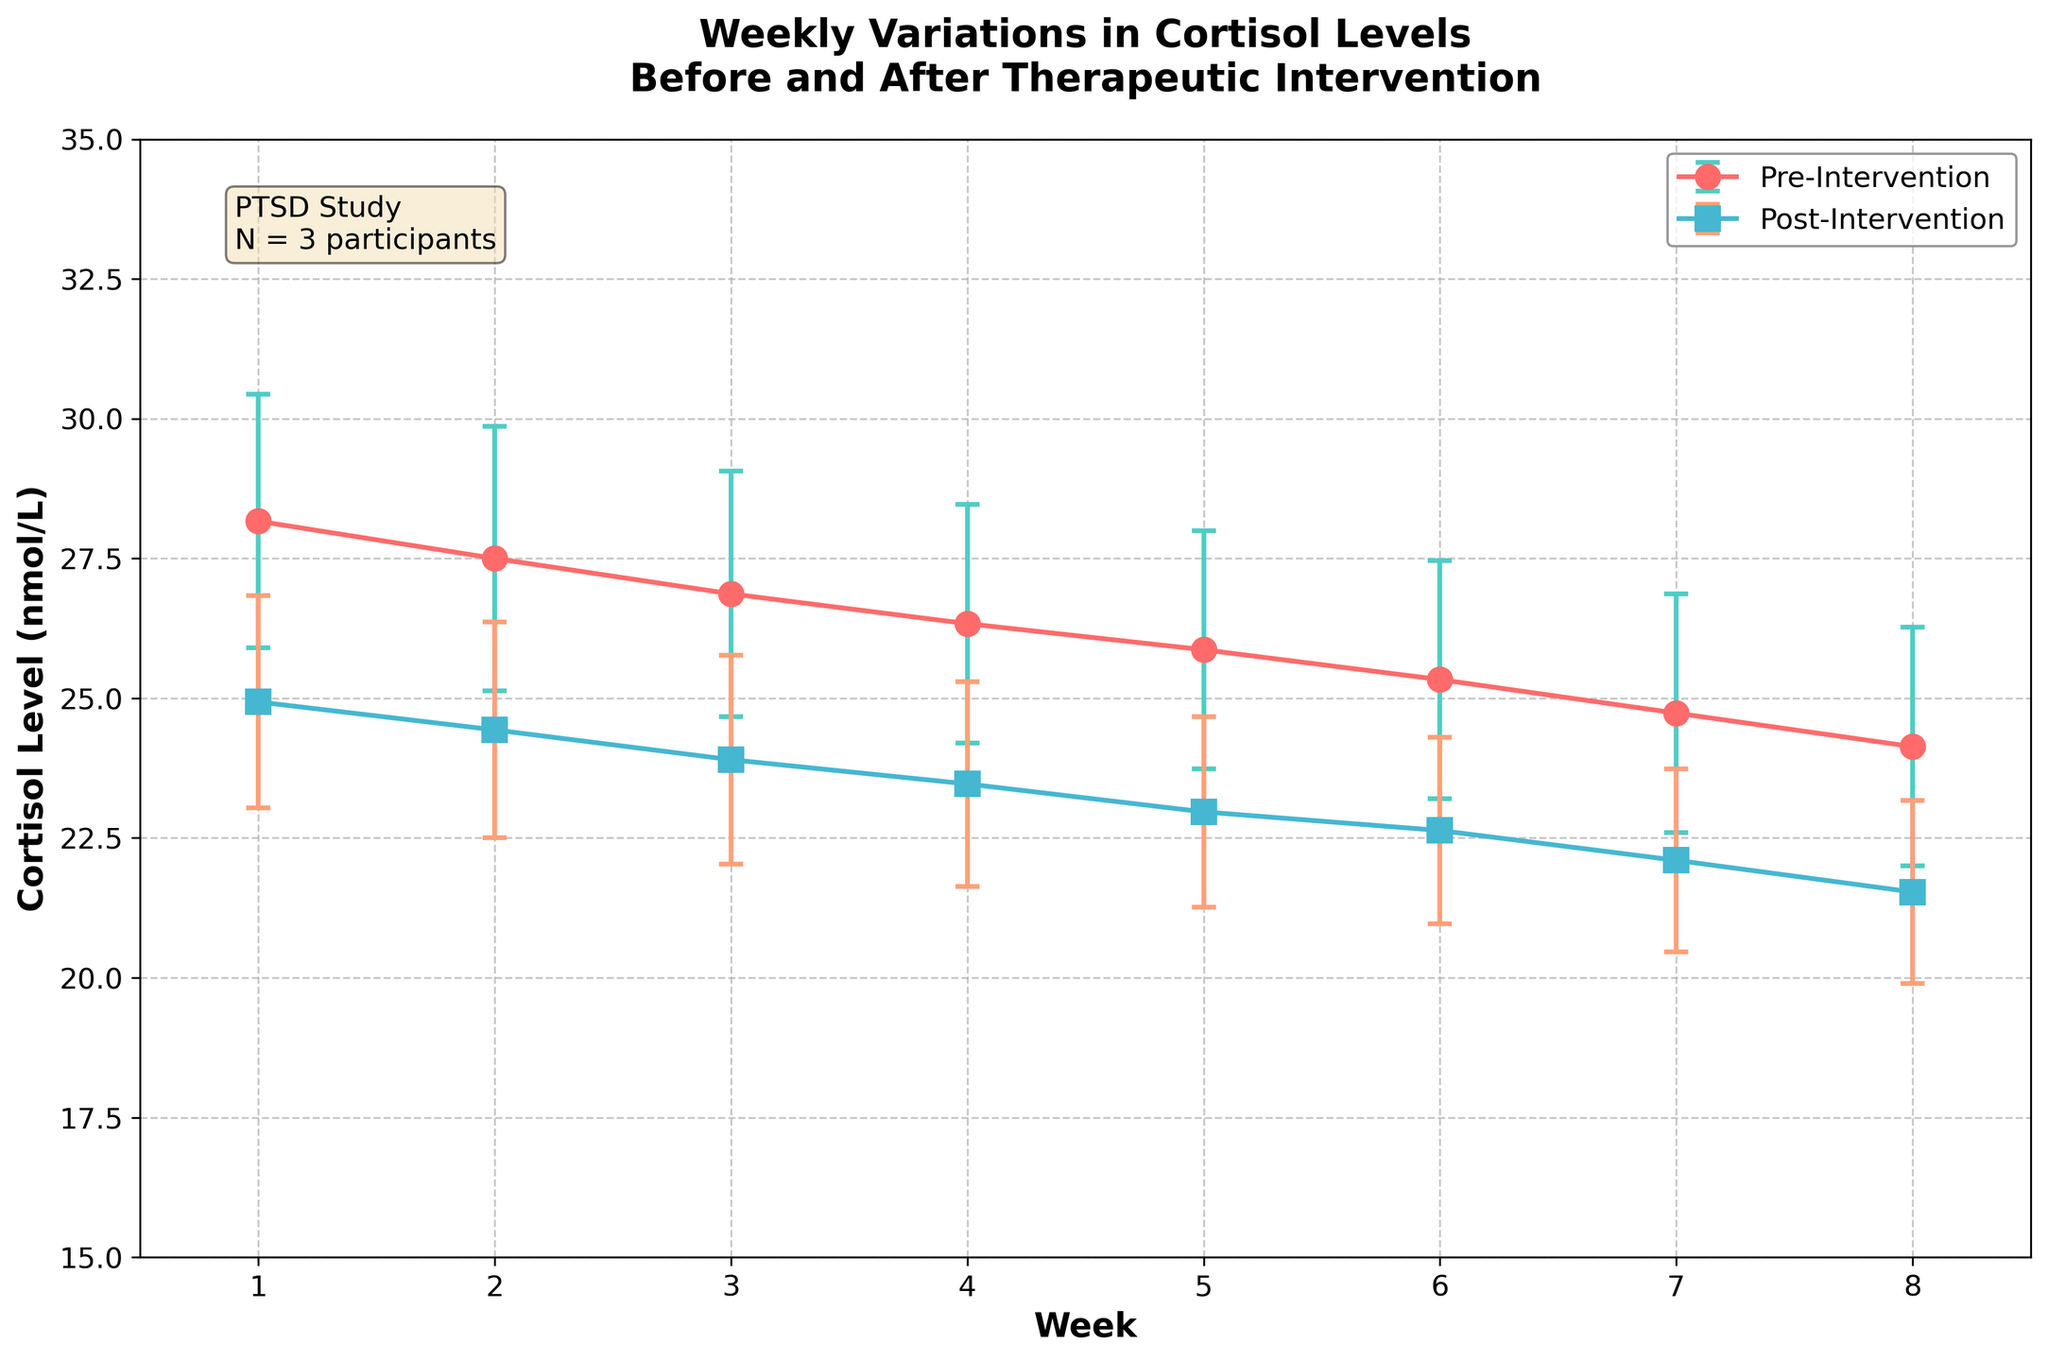What is the title of the figure? The title can be found at the top of the figure, usually in a larger and bolder font. In this case, it reads 'Weekly Variations in Cortisol Levels Before and After Therapeutic Intervention'.
Answer: Weekly Variations in Cortisol Levels Before and After Therapeutic Intervention What colors are used to represent the pre- and post-intervention data? By observing the figure, you can see the pre-intervention data is represented using a red color, and the post-intervention data is represented using a blue color.
Answer: Red, Blue Which week shows the highest average cortisol level pre-intervention? Looking at the plot's error bars and means, you identify Week 1 has the highest average cortisol level before intervention.
Answer: Week 1 Is there a general trend in cortisol levels post-intervention from Week 1 to Week 8? By examining the post-intervention line, you can see a downward trend in cortisol levels from Week 1 to Week 8.
Answer: Downward trend What is the cortisol level for John Doe in Week 1 pre- and post-intervention? Locate the Week 1 data points for John Doe on both lines; John Doe's cortisol level is 25.3 nmol/L pre-intervention and 22.1 nmol/L post-intervention.
Answer: 25.3 nmol/L, 22.1 nmol/L How do the error bars for the pre-intervention and post-intervention cortisol levels compare across the weeks? Observing the error bars, you can see that the pre-intervention error bars are generally larger than the post-intervention error bars, indicating more variability in pre-intervention levels.
Answer: Pre-intervention error bars are larger Which week shows the greatest difference in average cortisol levels pre- and post-intervention? Subtract the post-intervention averages from the pre-intervention averages for each week to find the largest difference. Week 1 shows the greatest difference with pre-intervention at 28.17 nmol/L and post-intervention at 24.93 nmol/L for a difference of 3.24 nmol/L.
Answer: Week 1 What is the average pre-intervention cortisol level for all participants in Week 4? By looking at the plot or using the mean indicated, the average pre-intervention cortisol level for Week 4 can be calculated as 23.7 + 28.4 + 26.9 divided by 3, which is 26.33 nmol/L.
Answer: 26.33 nmol/L What additional information is provided in the text box within the figure? The text box usually contains supplementary information; here it reads 'PTSD Study\nN = 3 participants'.
Answer: PTSD Study\nN = 3 participants 